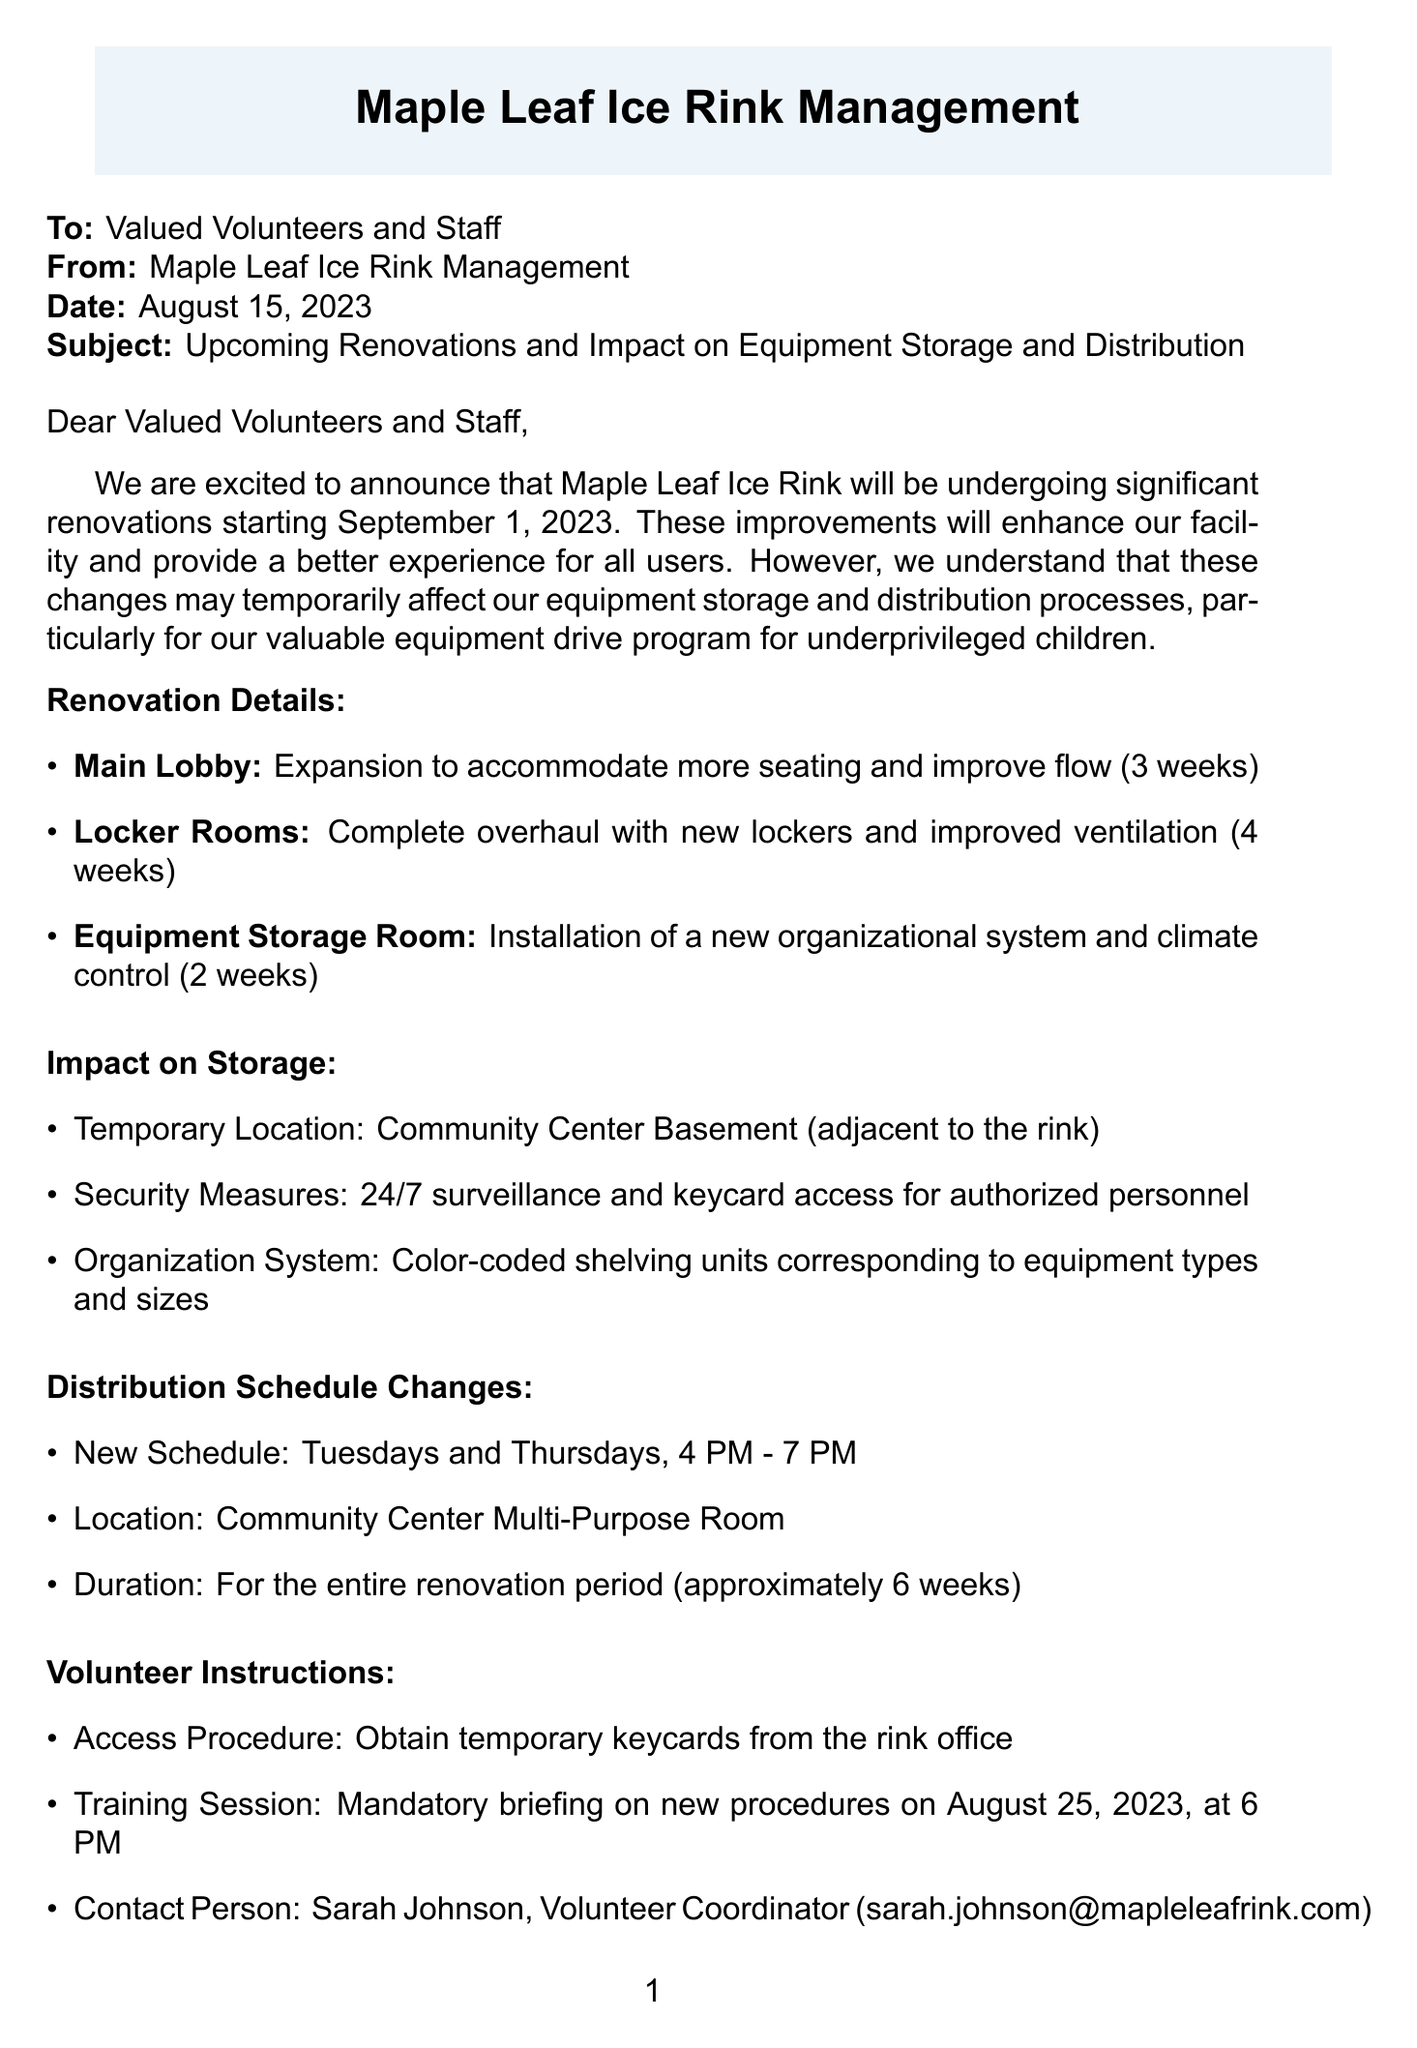what is the start date of the renovations? The letter states that renovations will begin on September 1, 2023.
Answer: September 1, 2023 how long will the equipment storage room renovations take? The duration for the equipment storage room renovations is specified in the document.
Answer: 2 weeks where will the temporary storage be located? The document mentions the temporary location for equipment storage during renovations.
Answer: Community Center Basement what are the new distribution days for equipment? The letter provides information about the new distribution schedule.
Answer: Tuesdays and Thursdays who is the contact person for volunteers? The document lists a contact person for volunteers regarding new procedures.
Answer: Sarah Johnson how many weeks will the renovations last in total? To get the total duration, one would add the individual renovation durations given for different areas.
Answer: 6 weeks what is one benefit of the renovations? The letter outlines multiple benefits of the renovations for storage and organization.
Answer: Increased storage capacity when is the mandatory training session for volunteers? The document specifies the date and time for the training session.
Answer: August 25, 2023, at 6 PM what security measure will be implemented for the temporary location? The letter details the security measures that will be taken during the renovation period.
Answer: 24/7 surveillance and keycard access 